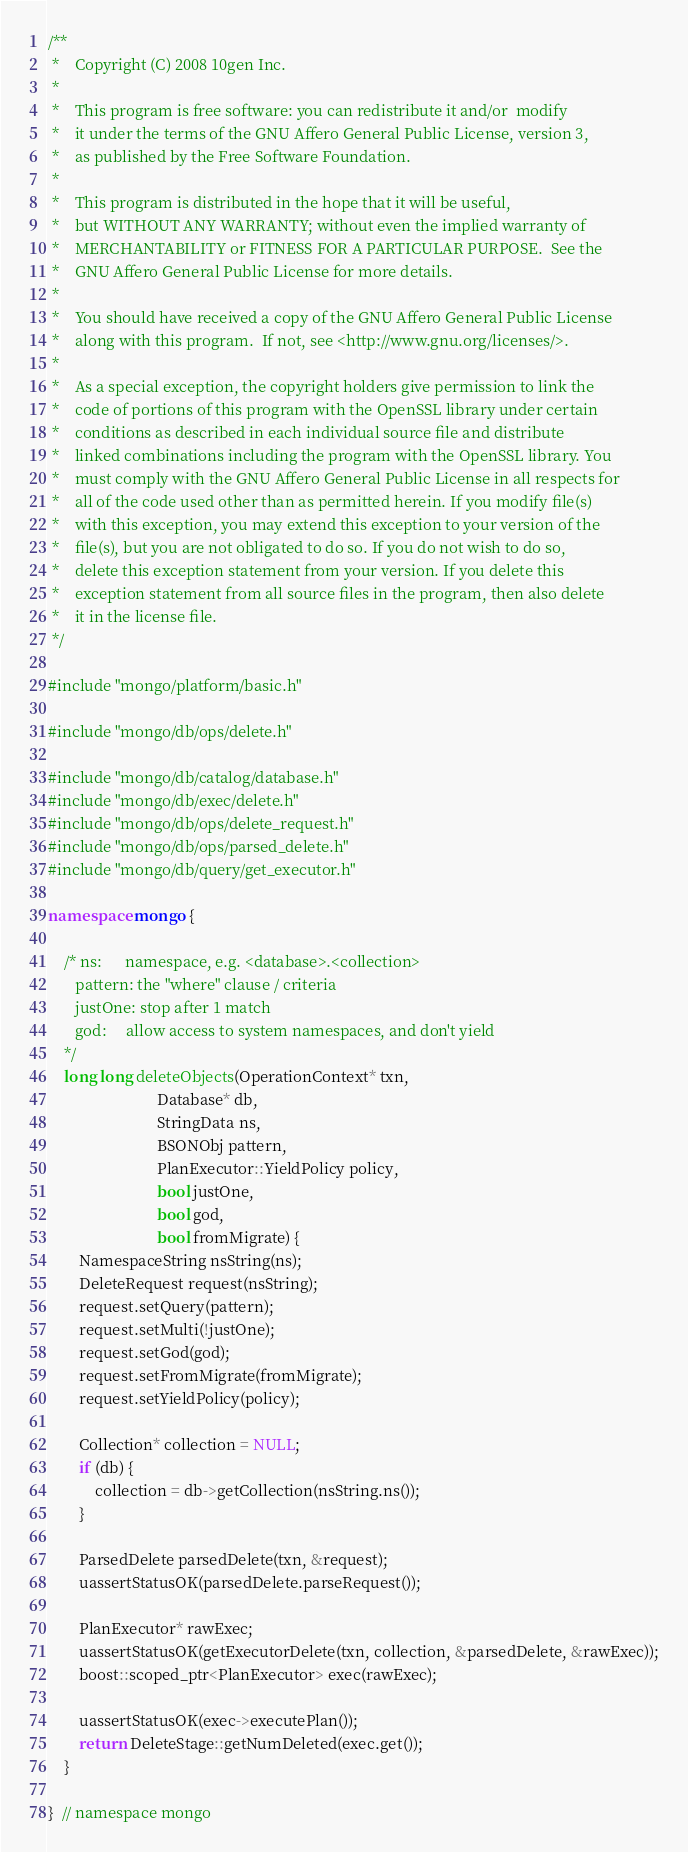<code> <loc_0><loc_0><loc_500><loc_500><_C++_>/**
 *    Copyright (C) 2008 10gen Inc.
 *
 *    This program is free software: you can redistribute it and/or  modify
 *    it under the terms of the GNU Affero General Public License, version 3,
 *    as published by the Free Software Foundation.
 *
 *    This program is distributed in the hope that it will be useful,
 *    but WITHOUT ANY WARRANTY; without even the implied warranty of
 *    MERCHANTABILITY or FITNESS FOR A PARTICULAR PURPOSE.  See the
 *    GNU Affero General Public License for more details.
 *
 *    You should have received a copy of the GNU Affero General Public License
 *    along with this program.  If not, see <http://www.gnu.org/licenses/>.
 *
 *    As a special exception, the copyright holders give permission to link the
 *    code of portions of this program with the OpenSSL library under certain
 *    conditions as described in each individual source file and distribute
 *    linked combinations including the program with the OpenSSL library. You
 *    must comply with the GNU Affero General Public License in all respects for
 *    all of the code used other than as permitted herein. If you modify file(s)
 *    with this exception, you may extend this exception to your version of the
 *    file(s), but you are not obligated to do so. If you do not wish to do so,
 *    delete this exception statement from your version. If you delete this
 *    exception statement from all source files in the program, then also delete
 *    it in the license file.
 */

#include "mongo/platform/basic.h"

#include "mongo/db/ops/delete.h"

#include "mongo/db/catalog/database.h"
#include "mongo/db/exec/delete.h"
#include "mongo/db/ops/delete_request.h"
#include "mongo/db/ops/parsed_delete.h"
#include "mongo/db/query/get_executor.h"

namespace mongo {

    /* ns:      namespace, e.g. <database>.<collection>
       pattern: the "where" clause / criteria
       justOne: stop after 1 match
       god:     allow access to system namespaces, and don't yield
    */
    long long deleteObjects(OperationContext* txn,
                            Database* db,
                            StringData ns,
                            BSONObj pattern,
                            PlanExecutor::YieldPolicy policy,
                            bool justOne,
                            bool god,
                            bool fromMigrate) {
        NamespaceString nsString(ns);
        DeleteRequest request(nsString);
        request.setQuery(pattern);
        request.setMulti(!justOne);
        request.setGod(god);
        request.setFromMigrate(fromMigrate);
        request.setYieldPolicy(policy);

        Collection* collection = NULL;
        if (db) {
            collection = db->getCollection(nsString.ns());
        }

        ParsedDelete parsedDelete(txn, &request);
        uassertStatusOK(parsedDelete.parseRequest());

        PlanExecutor* rawExec;
        uassertStatusOK(getExecutorDelete(txn, collection, &parsedDelete, &rawExec));
        boost::scoped_ptr<PlanExecutor> exec(rawExec);

        uassertStatusOK(exec->executePlan());
        return DeleteStage::getNumDeleted(exec.get());
    }

}  // namespace mongo
</code> 